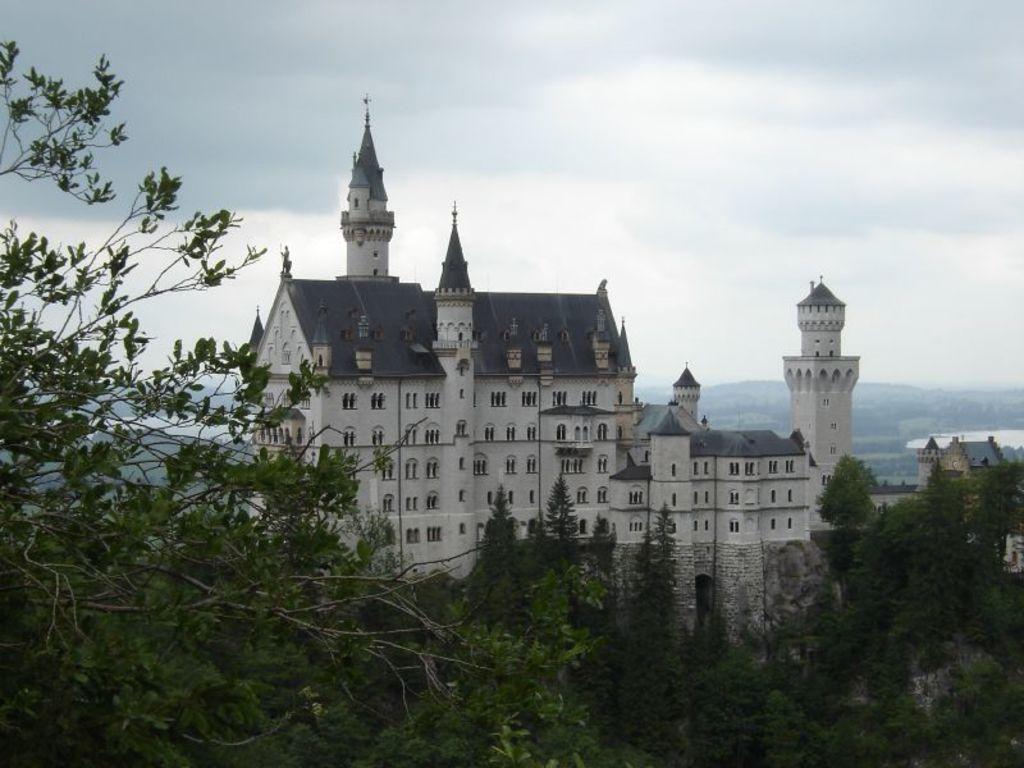In one or two sentences, can you explain what this image depicts? In the picture I can see buildings and trees. In the background I can see the sky. 